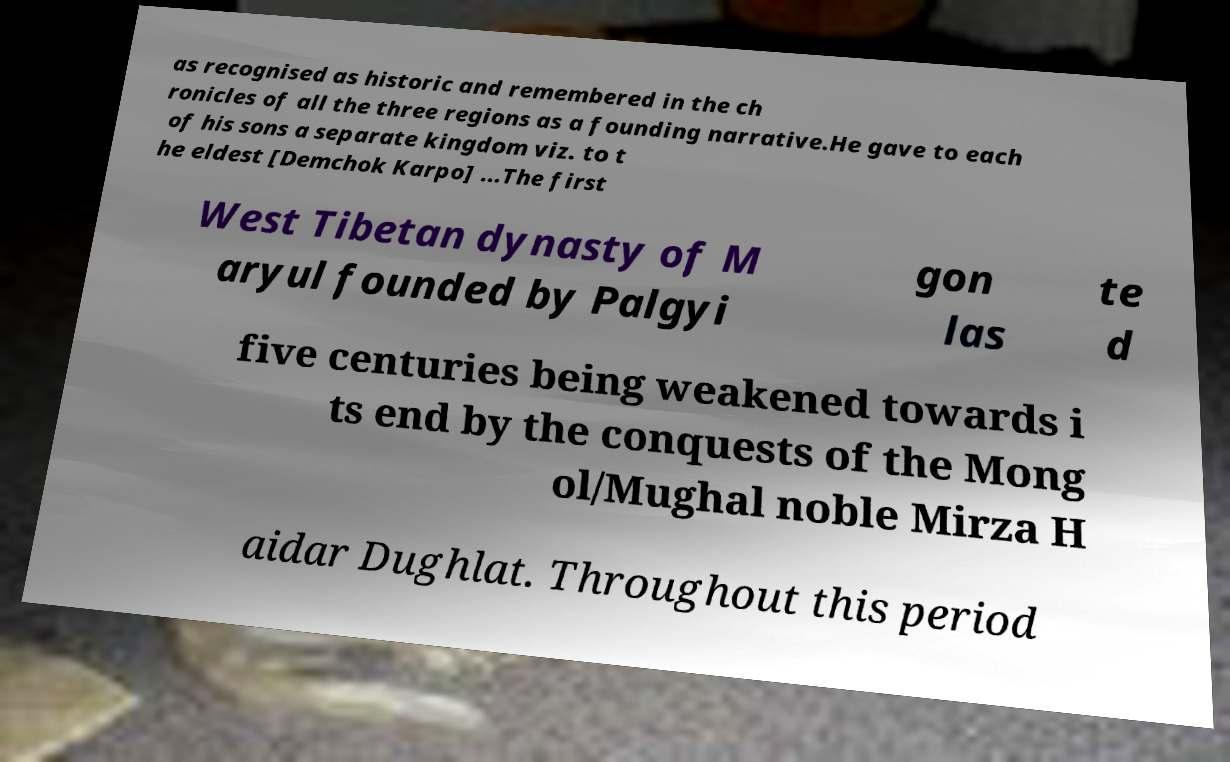Could you assist in decoding the text presented in this image and type it out clearly? as recognised as historic and remembered in the ch ronicles of all the three regions as a founding narrative.He gave to each of his sons a separate kingdom viz. to t he eldest [Demchok Karpo] ...The first West Tibetan dynasty of M aryul founded by Palgyi gon las te d five centuries being weakened towards i ts end by the conquests of the Mong ol/Mughal noble Mirza H aidar Dughlat. Throughout this period 